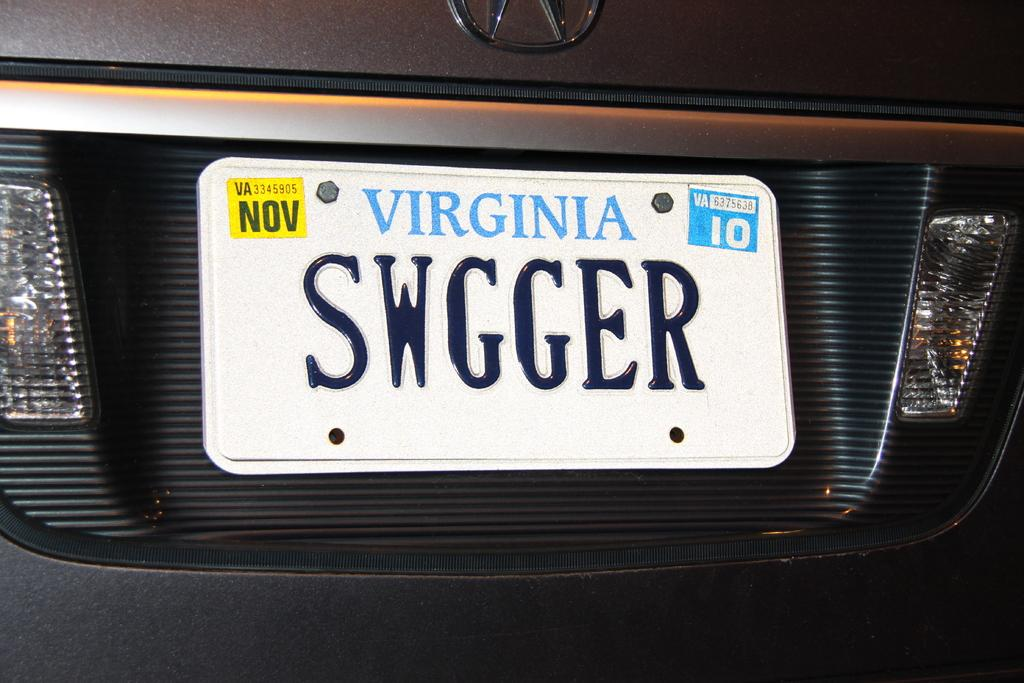<image>
Offer a succinct explanation of the picture presented. A Virginia license plate has November tags and says SWGGER. 